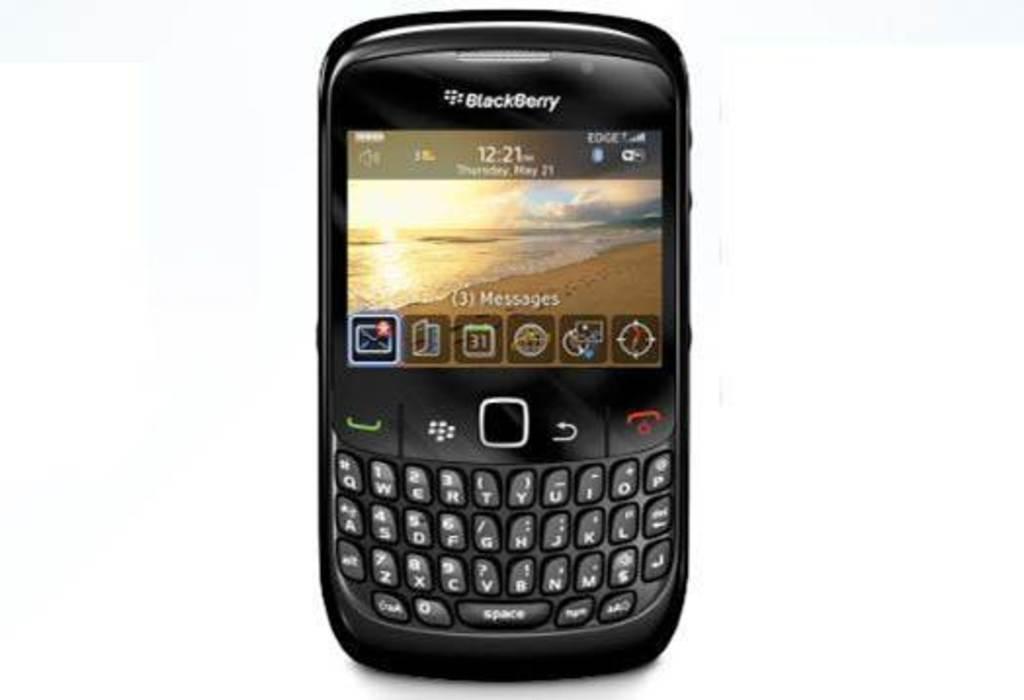Can you describe this image briefly? In this image, this looks like a blackberry mobile phone. This is a keypad and the buttons. I can see the screen with the display. This mobile phone is black in color. I can see the apps and wallpaper in the display. 